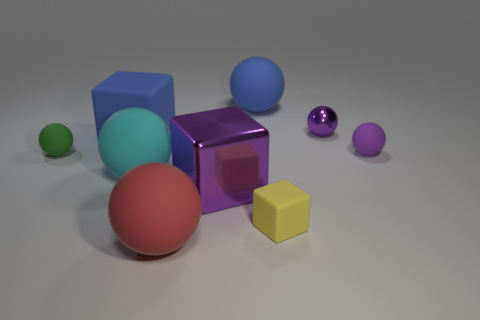Subtract all big cubes. How many cubes are left? 1 Subtract all yellow cylinders. How many green spheres are left? 1 Subtract all blue rubber things. Subtract all big blue blocks. How many objects are left? 6 Add 4 cyan matte spheres. How many cyan matte spheres are left? 5 Add 7 small yellow rubber things. How many small yellow rubber things exist? 8 Subtract all green balls. How many balls are left? 5 Subtract 1 red balls. How many objects are left? 8 Subtract all spheres. How many objects are left? 3 Subtract 3 blocks. How many blocks are left? 0 Subtract all red blocks. Subtract all purple cylinders. How many blocks are left? 3 